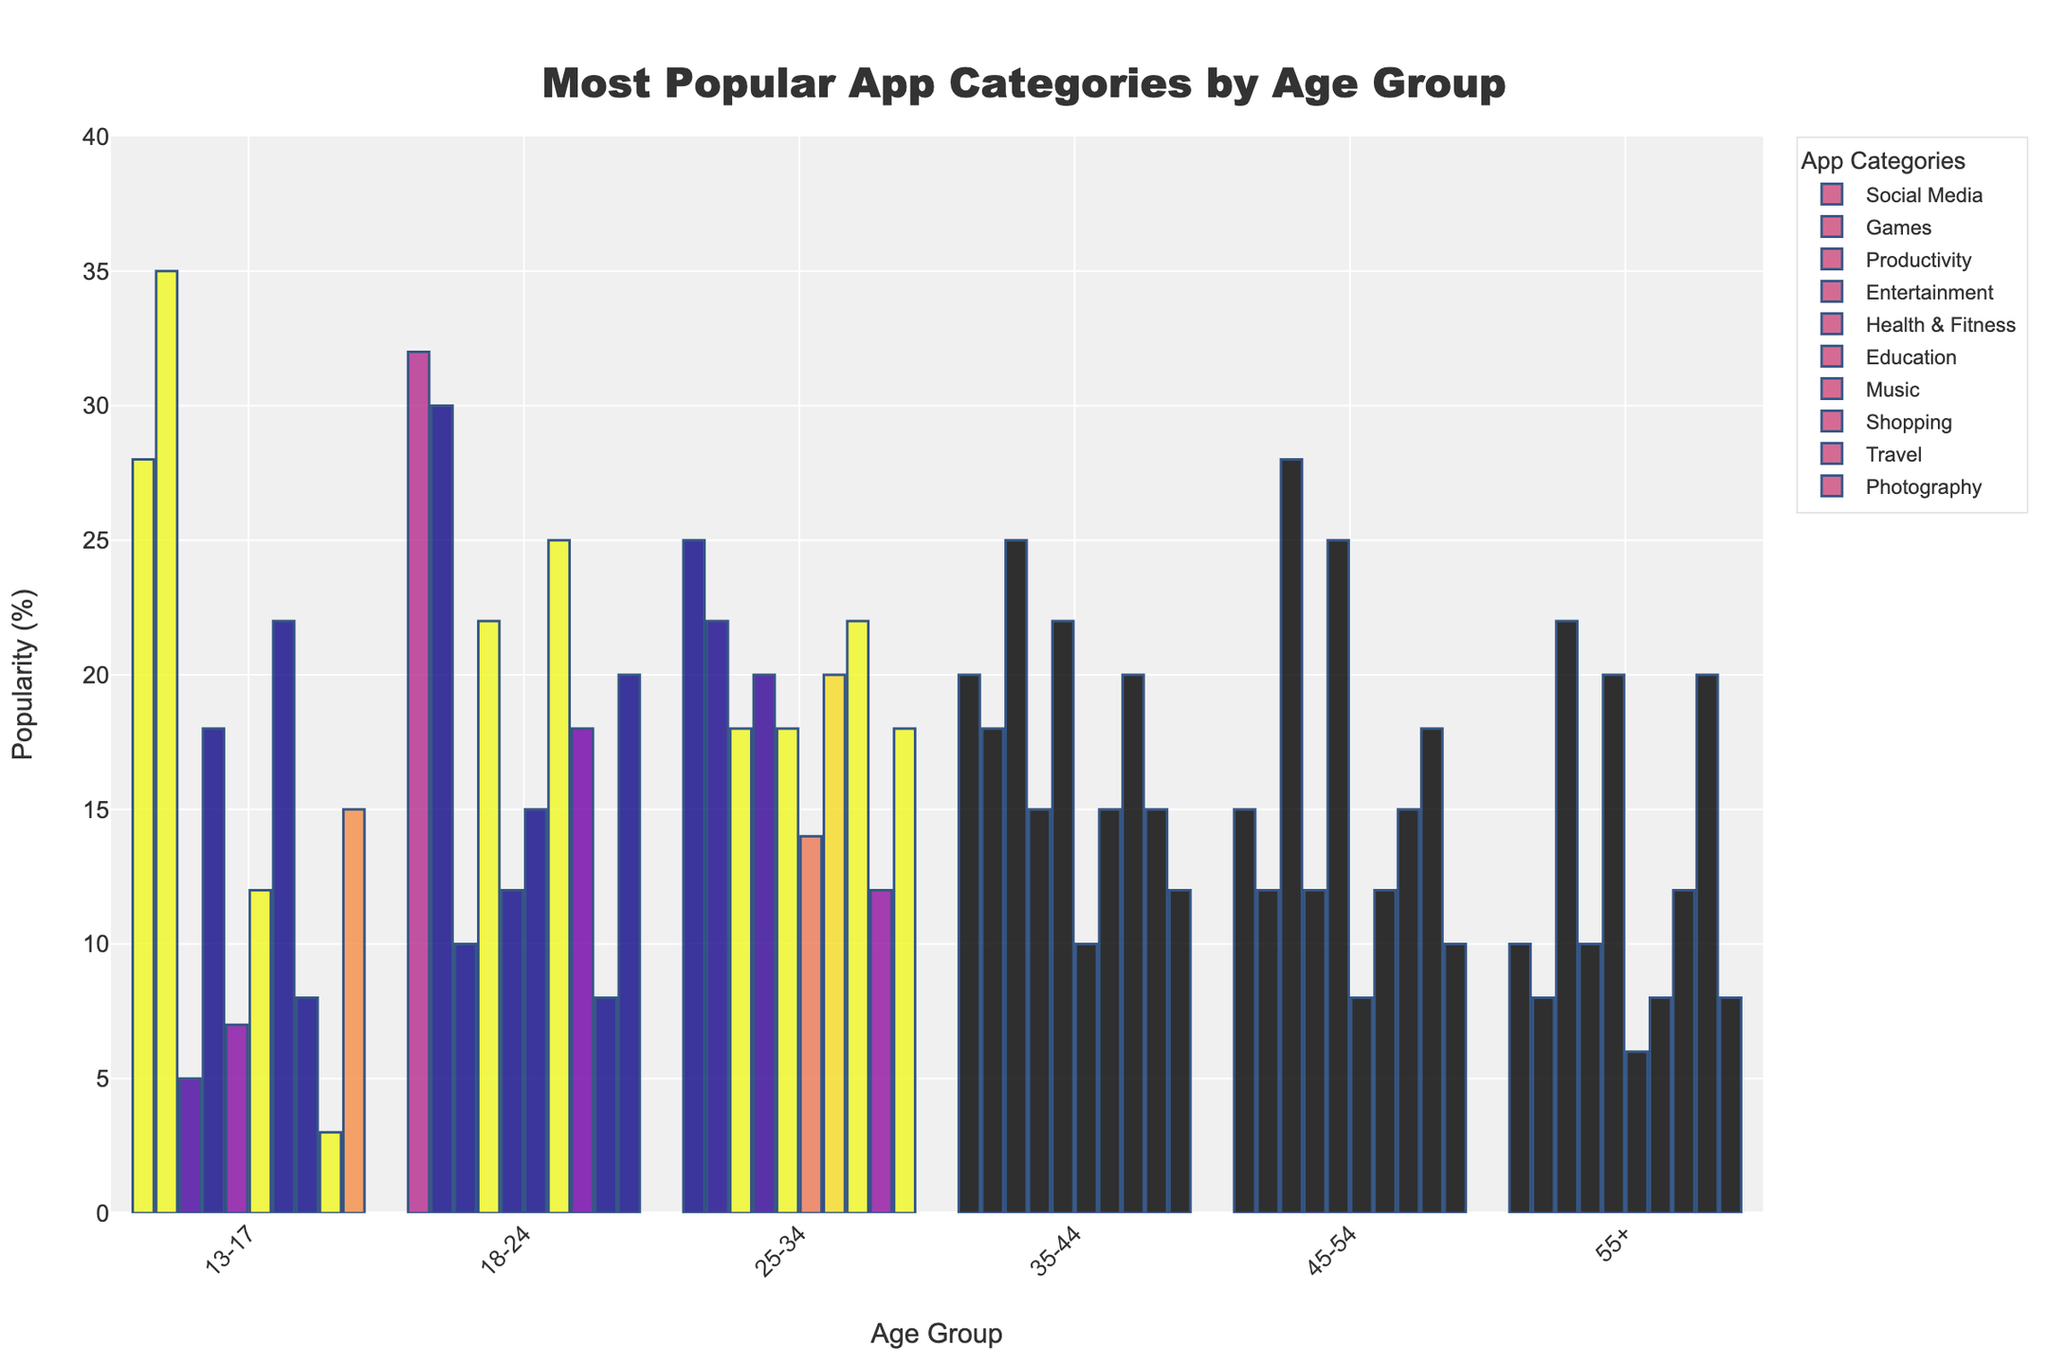Which age group finds social media most popular? By looking at the chart, the age group 18-24 has the highest bar for social media, indicating it is the most popular category for this age group.
Answer: 18-24 In which age group is the games category least popular? The chart shows that the 55+ age group has the shortest bar for the games category, indicating it is the least popular category for this age group.
Answer: 55+ Comparing social media and gaming, which category is more popular for the 13-17 age group? For the 13-17 age group, the bar for games is taller than the bar for social media, showing that games are more popular.
Answer: Games What is the difference in popularity of health & fitness apps between age groups 35-44 and 55+? The bar for health & fitness is at 22 for 35-44 and at 20 for 55+, so the difference is 22 - 20.
Answer: 2 Which three age groups have the highest popularity for productivity apps, and what are their values? The highest bars for productivity apps are in age groups 45-54, 35-44, and 25-34, with values of 28, 25, and 18 respectively.
Answer: 45-54 (28), 35-44 (25), 25-34 (18) Are music apps more popular among the 18-24 age group or the 35-44 age group, and by how much? The bar for music apps is at 25 for 18-24 and at 15 for 35-44. The popularity difference is 25 - 15.
Answer: 18-24 (by 10) What is the average popularity of education apps across all age groups? The values are 12, 15, 14, 10, 8, and 6. The sum is 65 (12 + 15 + 14 + 10 + 8 + 6) and the average is 65 divided by 6.
Answer: 10.83 Which age group finds shopping apps the second most popular, and what are the first and second most popular categories? For the age group 25-34, music is the most popular and shopping is the second most popular.
Answer: 25-34 (most: music, second: shopping) How does the popularity of photography apps change from age group 13-17 to 55+? The popularity of photography apps starts at 15 for 13-17 and decreases to 8 for 55+. The trend shows a decrease.
Answer: Decreases 